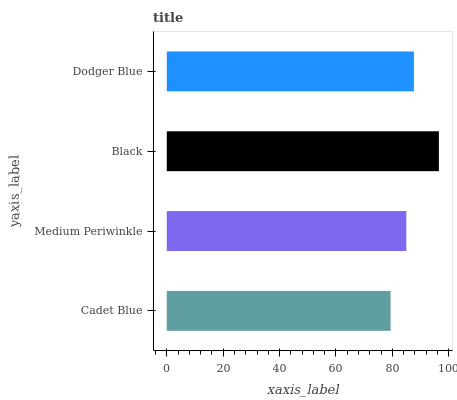Is Cadet Blue the minimum?
Answer yes or no. Yes. Is Black the maximum?
Answer yes or no. Yes. Is Medium Periwinkle the minimum?
Answer yes or no. No. Is Medium Periwinkle the maximum?
Answer yes or no. No. Is Medium Periwinkle greater than Cadet Blue?
Answer yes or no. Yes. Is Cadet Blue less than Medium Periwinkle?
Answer yes or no. Yes. Is Cadet Blue greater than Medium Periwinkle?
Answer yes or no. No. Is Medium Periwinkle less than Cadet Blue?
Answer yes or no. No. Is Dodger Blue the high median?
Answer yes or no. Yes. Is Medium Periwinkle the low median?
Answer yes or no. Yes. Is Cadet Blue the high median?
Answer yes or no. No. Is Cadet Blue the low median?
Answer yes or no. No. 